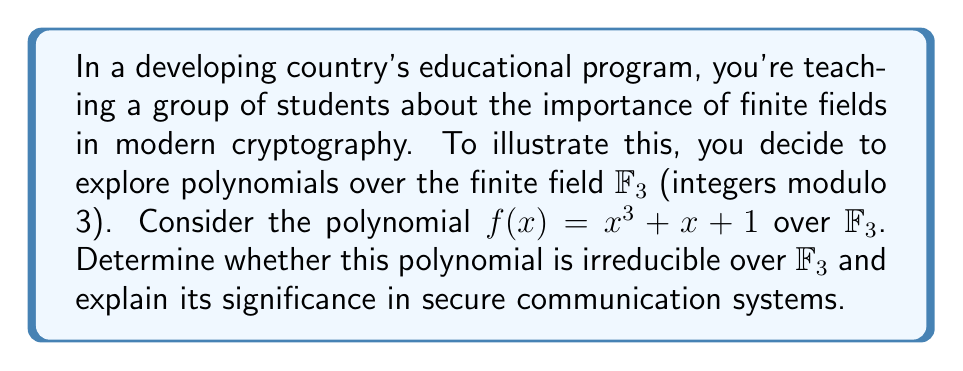Could you help me with this problem? Let's approach this step-by-step:

1) To determine if $f(x) = x^3 + x + 1$ is irreducible over $\mathbb{F}_3$, we need to check if it has any factors of degree 1 or 2.

2) For degree 1 factors, we check if $f(x)$ has any roots in $\mathbb{F}_3$. We evaluate $f(x)$ for $x = 0, 1, 2$:

   $f(0) = 0^3 + 0 + 1 \equiv 1 \pmod{3}$
   $f(1) = 1^3 + 1 + 1 \equiv 0 \pmod{3}$
   $f(2) = 2^3 + 2 + 1 \equiv 1 \pmod{3}$

3) We find that $f(1) \equiv 0 \pmod{3}$, so $x - 1$ is a factor of $f(x)$ over $\mathbb{F}_3$.

4) We can divide $f(x)$ by $(x - 1)$ to get the other factor:

   $f(x) = (x - 1)(x^2 + x + 2)$

5) Therefore, $f(x)$ is reducible over $\mathbb{F}_3$.

Significance in secure communication:

6) Irreducible polynomials over finite fields are crucial in cryptography, particularly in the construction of secure pseudorandom number generators and in error-correcting codes.

7) While our polynomial is not irreducible, understanding polynomial factorization over finite fields is essential for:
   - Designing and analyzing cryptographic algorithms
   - Implementing efficient error detection and correction in digital communications
   - Developing secure hashing functions

8) In developing countries, where internet infrastructure may be limited, robust cryptographic systems are vital for protecting sensitive information and enabling secure e-commerce and digital governance initiatives.
Answer: Reducible; $f(x) = (x - 1)(x^2 + x + 2)$ over $\mathbb{F}_3$ 